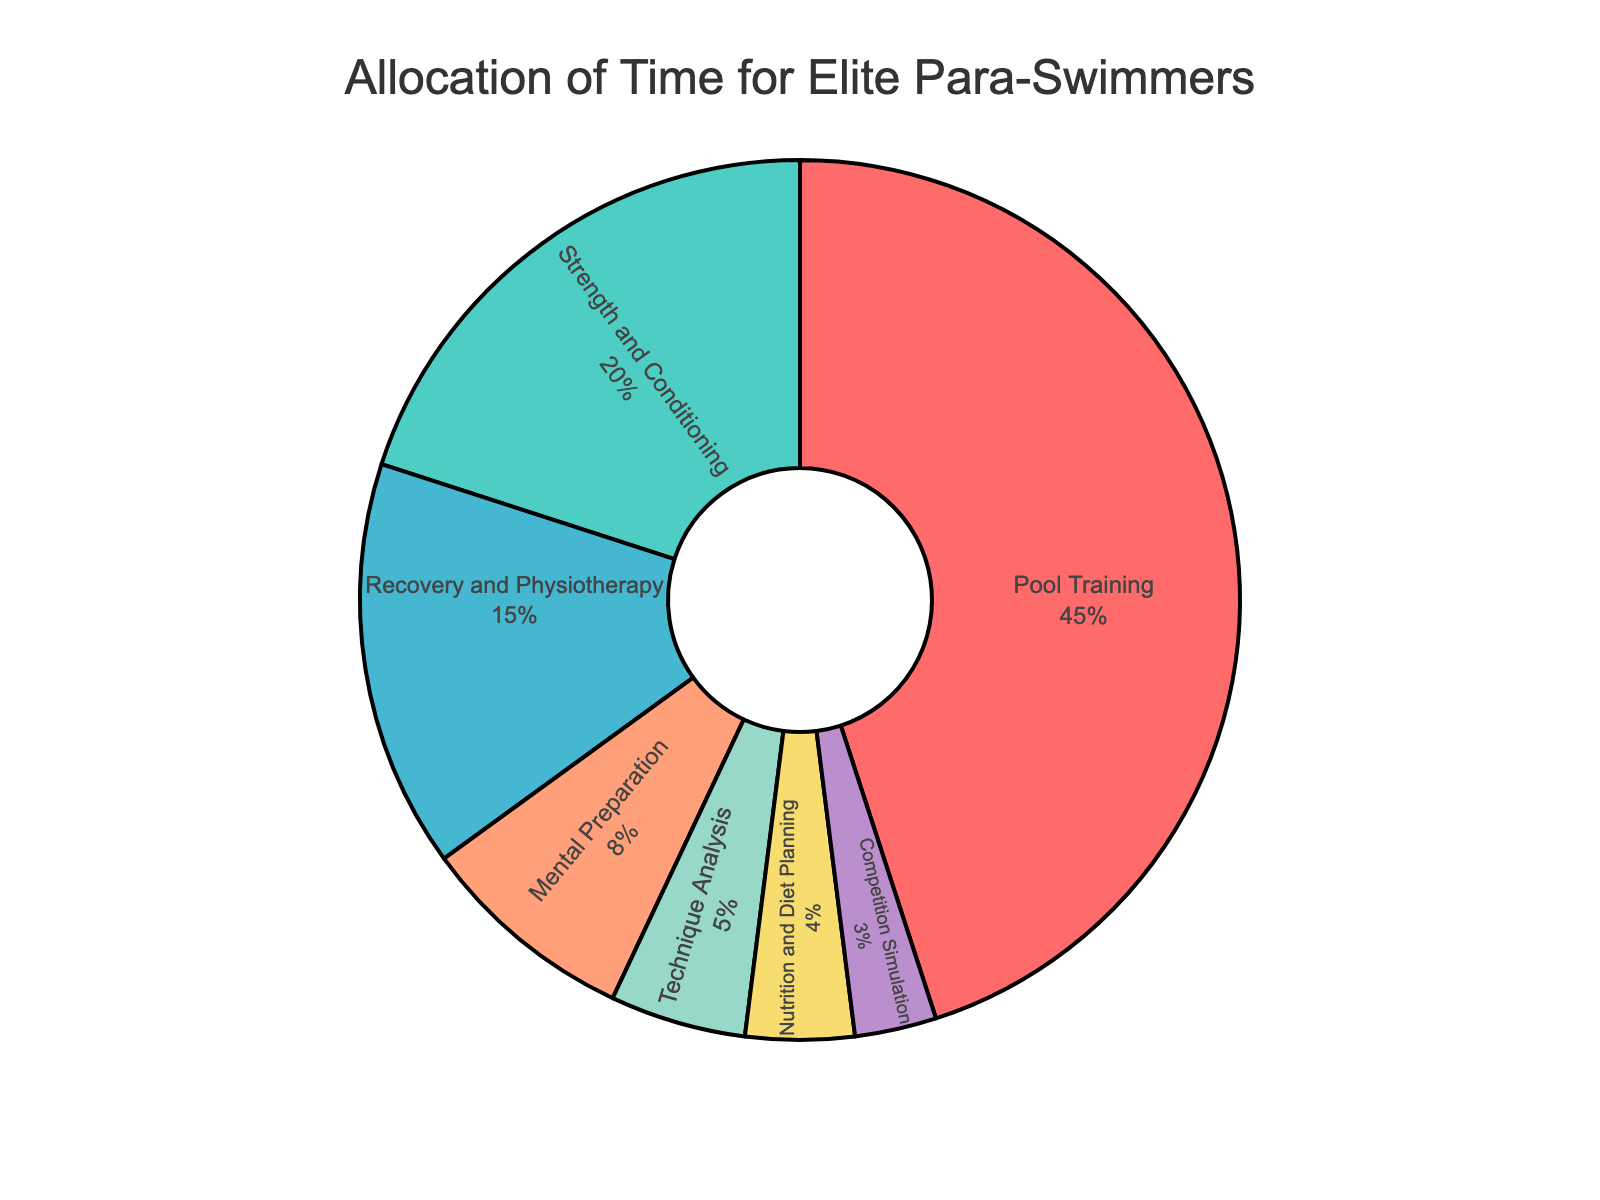What's the largest training activity for elite para-swimmers? The largest percentage slice in the pie chart represents Pool Training, which is labeled with both the activity name and the percentage.
Answer: Pool Training What's the total percentage of time allocated to Strength and Conditioning and Mental Preparation? Add the percentage values of Strength and Conditioning (20%) and Mental Preparation (8%). This gives 20 + 8 = 28%.
Answer: 28% How much more time is spent on Recovery and Physiotherapy compared to Technique Analysis? Subtract the percentage of Technique Analysis (5%) from Recovery and Physiotherapy (15%). This gives 15 - 5 = 10%.
Answer: 10% Which activity has the smallest allocation of time? The smallest percentage slice in the pie chart represents Competition Simulation, which is labeled with the activity name and the percentage.
Answer: Competition Simulation What's the percentage difference between Pool Training and Strength and Conditioning? Subtract the percentage of Strength and Conditioning (20%) from Pool Training (45%). This gives 45 - 20 = 25%.
Answer: 25% What is the combined percentage for Nutrition and Diet Planning, and Competition Simulation? Add the percentage values of Nutrition and Diet Planning (4%) and Competition Simulation (3%). This gives 4 + 3 = 7%.
Answer: 7% Is the time spent on Recovery and Physiotherapy greater than on Strength and Conditioning? Compare the percentages: Recovery and Physiotherapy (15%) is less than Strength and Conditioning (20%).
Answer: No Which color represents the most significant activity in the pie chart? The largest slice regarding Pool Training is represented by the red color.
Answer: Red 